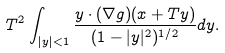Convert formula to latex. <formula><loc_0><loc_0><loc_500><loc_500>T ^ { 2 } \int _ { | y | < 1 } \frac { y \cdot ( \nabla g ) ( x + T y ) } { ( 1 - | y | ^ { 2 } ) ^ { 1 / 2 } } d y .</formula> 